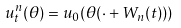Convert formula to latex. <formula><loc_0><loc_0><loc_500><loc_500>u _ { t } ^ { n } ( \theta ) = u _ { 0 } ( \theta ( \cdot + W _ { n } ( t ) ) )</formula> 